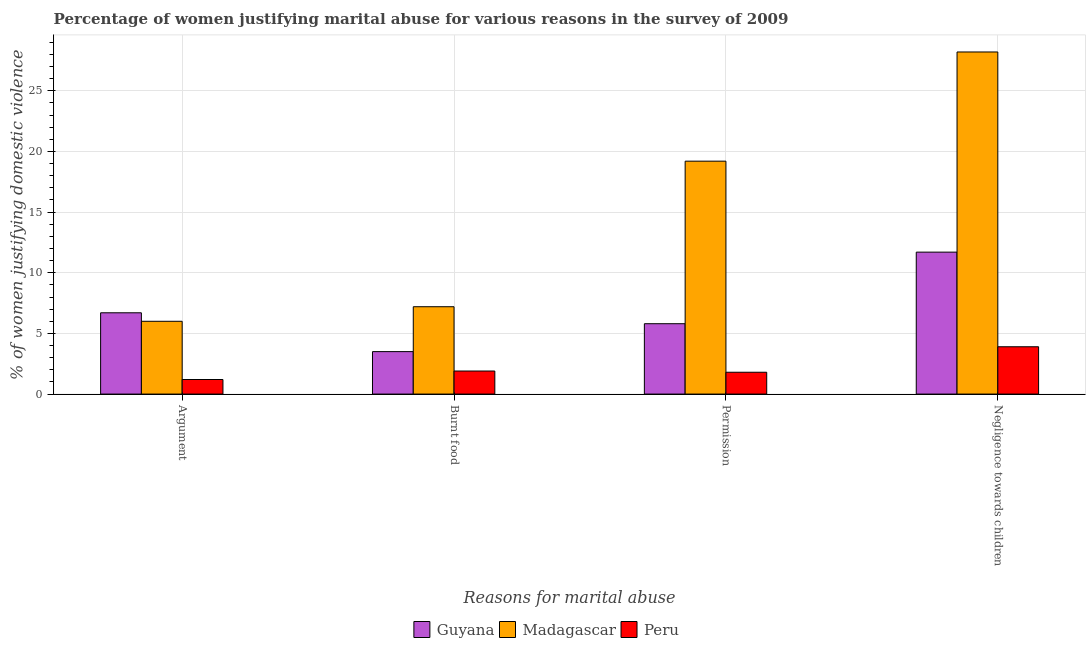How many different coloured bars are there?
Keep it short and to the point. 3. How many groups of bars are there?
Provide a short and direct response. 4. Are the number of bars on each tick of the X-axis equal?
Ensure brevity in your answer.  Yes. How many bars are there on the 1st tick from the left?
Make the answer very short. 3. How many bars are there on the 1st tick from the right?
Provide a succinct answer. 3. What is the label of the 1st group of bars from the left?
Offer a very short reply. Argument. Across all countries, what is the maximum percentage of women justifying abuse for burning food?
Your answer should be very brief. 7.2. Across all countries, what is the minimum percentage of women justifying abuse for going without permission?
Ensure brevity in your answer.  1.8. In which country was the percentage of women justifying abuse in the case of an argument maximum?
Your response must be concise. Guyana. What is the difference between the percentage of women justifying abuse for going without permission in Peru and that in Guyana?
Your answer should be very brief. -4. What is the difference between the percentage of women justifying abuse for burning food in Guyana and the percentage of women justifying abuse for going without permission in Peru?
Make the answer very short. 1.7. What is the average percentage of women justifying abuse for burning food per country?
Offer a terse response. 4.2. In how many countries, is the percentage of women justifying abuse for going without permission greater than 4 %?
Give a very brief answer. 2. What is the ratio of the percentage of women justifying abuse in the case of an argument in Peru to that in Guyana?
Your response must be concise. 0.18. Is the difference between the percentage of women justifying abuse in the case of an argument in Peru and Guyana greater than the difference between the percentage of women justifying abuse for going without permission in Peru and Guyana?
Your response must be concise. No. What is the difference between the highest and the lowest percentage of women justifying abuse for burning food?
Offer a very short reply. 5.3. Is the sum of the percentage of women justifying abuse for going without permission in Peru and Guyana greater than the maximum percentage of women justifying abuse for burning food across all countries?
Offer a terse response. Yes. What does the 3rd bar from the left in Negligence towards children represents?
Offer a very short reply. Peru. What does the 2nd bar from the right in Argument represents?
Your answer should be compact. Madagascar. Are all the bars in the graph horizontal?
Give a very brief answer. No. What is the difference between two consecutive major ticks on the Y-axis?
Provide a short and direct response. 5. Does the graph contain any zero values?
Your response must be concise. No. How many legend labels are there?
Make the answer very short. 3. What is the title of the graph?
Provide a short and direct response. Percentage of women justifying marital abuse for various reasons in the survey of 2009. Does "Ukraine" appear as one of the legend labels in the graph?
Make the answer very short. No. What is the label or title of the X-axis?
Ensure brevity in your answer.  Reasons for marital abuse. What is the label or title of the Y-axis?
Keep it short and to the point. % of women justifying domestic violence. What is the % of women justifying domestic violence in Madagascar in Argument?
Keep it short and to the point. 6. What is the % of women justifying domestic violence in Peru in Argument?
Provide a short and direct response. 1.2. What is the % of women justifying domestic violence of Guyana in Burnt food?
Keep it short and to the point. 3.5. What is the % of women justifying domestic violence in Madagascar in Burnt food?
Ensure brevity in your answer.  7.2. What is the % of women justifying domestic violence in Peru in Burnt food?
Provide a short and direct response. 1.9. What is the % of women justifying domestic violence in Guyana in Permission?
Provide a succinct answer. 5.8. What is the % of women justifying domestic violence in Madagascar in Permission?
Your answer should be compact. 19.2. What is the % of women justifying domestic violence in Peru in Permission?
Provide a short and direct response. 1.8. What is the % of women justifying domestic violence in Madagascar in Negligence towards children?
Offer a terse response. 28.2. Across all Reasons for marital abuse, what is the maximum % of women justifying domestic violence of Madagascar?
Give a very brief answer. 28.2. Across all Reasons for marital abuse, what is the maximum % of women justifying domestic violence in Peru?
Make the answer very short. 3.9. Across all Reasons for marital abuse, what is the minimum % of women justifying domestic violence of Guyana?
Keep it short and to the point. 3.5. Across all Reasons for marital abuse, what is the minimum % of women justifying domestic violence of Peru?
Offer a terse response. 1.2. What is the total % of women justifying domestic violence of Guyana in the graph?
Your answer should be compact. 27.7. What is the total % of women justifying domestic violence of Madagascar in the graph?
Your response must be concise. 60.6. What is the difference between the % of women justifying domestic violence in Peru in Argument and that in Burnt food?
Provide a short and direct response. -0.7. What is the difference between the % of women justifying domestic violence of Guyana in Argument and that in Negligence towards children?
Offer a terse response. -5. What is the difference between the % of women justifying domestic violence in Madagascar in Argument and that in Negligence towards children?
Provide a succinct answer. -22.2. What is the difference between the % of women justifying domestic violence of Peru in Argument and that in Negligence towards children?
Provide a succinct answer. -2.7. What is the difference between the % of women justifying domestic violence in Madagascar in Burnt food and that in Permission?
Your answer should be compact. -12. What is the difference between the % of women justifying domestic violence of Guyana in Burnt food and that in Negligence towards children?
Give a very brief answer. -8.2. What is the difference between the % of women justifying domestic violence of Madagascar in Burnt food and that in Negligence towards children?
Provide a succinct answer. -21. What is the difference between the % of women justifying domestic violence in Peru in Burnt food and that in Negligence towards children?
Your answer should be compact. -2. What is the difference between the % of women justifying domestic violence of Madagascar in Permission and that in Negligence towards children?
Provide a succinct answer. -9. What is the difference between the % of women justifying domestic violence of Peru in Permission and that in Negligence towards children?
Ensure brevity in your answer.  -2.1. What is the difference between the % of women justifying domestic violence of Madagascar in Argument and the % of women justifying domestic violence of Peru in Permission?
Your answer should be very brief. 4.2. What is the difference between the % of women justifying domestic violence of Guyana in Argument and the % of women justifying domestic violence of Madagascar in Negligence towards children?
Provide a short and direct response. -21.5. What is the difference between the % of women justifying domestic violence of Guyana in Burnt food and the % of women justifying domestic violence of Madagascar in Permission?
Your answer should be very brief. -15.7. What is the difference between the % of women justifying domestic violence in Guyana in Burnt food and the % of women justifying domestic violence in Peru in Permission?
Make the answer very short. 1.7. What is the difference between the % of women justifying domestic violence in Guyana in Burnt food and the % of women justifying domestic violence in Madagascar in Negligence towards children?
Ensure brevity in your answer.  -24.7. What is the difference between the % of women justifying domestic violence of Madagascar in Burnt food and the % of women justifying domestic violence of Peru in Negligence towards children?
Give a very brief answer. 3.3. What is the difference between the % of women justifying domestic violence of Guyana in Permission and the % of women justifying domestic violence of Madagascar in Negligence towards children?
Your answer should be very brief. -22.4. What is the difference between the % of women justifying domestic violence of Guyana in Permission and the % of women justifying domestic violence of Peru in Negligence towards children?
Give a very brief answer. 1.9. What is the difference between the % of women justifying domestic violence in Madagascar in Permission and the % of women justifying domestic violence in Peru in Negligence towards children?
Your answer should be compact. 15.3. What is the average % of women justifying domestic violence in Guyana per Reasons for marital abuse?
Your answer should be compact. 6.92. What is the average % of women justifying domestic violence in Madagascar per Reasons for marital abuse?
Ensure brevity in your answer.  15.15. What is the difference between the % of women justifying domestic violence in Guyana and % of women justifying domestic violence in Madagascar in Argument?
Offer a very short reply. 0.7. What is the difference between the % of women justifying domestic violence in Madagascar and % of women justifying domestic violence in Peru in Argument?
Make the answer very short. 4.8. What is the difference between the % of women justifying domestic violence in Guyana and % of women justifying domestic violence in Peru in Burnt food?
Ensure brevity in your answer.  1.6. What is the difference between the % of women justifying domestic violence in Guyana and % of women justifying domestic violence in Madagascar in Permission?
Give a very brief answer. -13.4. What is the difference between the % of women justifying domestic violence in Guyana and % of women justifying domestic violence in Madagascar in Negligence towards children?
Ensure brevity in your answer.  -16.5. What is the difference between the % of women justifying domestic violence of Guyana and % of women justifying domestic violence of Peru in Negligence towards children?
Make the answer very short. 7.8. What is the difference between the % of women justifying domestic violence of Madagascar and % of women justifying domestic violence of Peru in Negligence towards children?
Make the answer very short. 24.3. What is the ratio of the % of women justifying domestic violence of Guyana in Argument to that in Burnt food?
Make the answer very short. 1.91. What is the ratio of the % of women justifying domestic violence of Peru in Argument to that in Burnt food?
Ensure brevity in your answer.  0.63. What is the ratio of the % of women justifying domestic violence of Guyana in Argument to that in Permission?
Your response must be concise. 1.16. What is the ratio of the % of women justifying domestic violence in Madagascar in Argument to that in Permission?
Your answer should be very brief. 0.31. What is the ratio of the % of women justifying domestic violence of Peru in Argument to that in Permission?
Your answer should be very brief. 0.67. What is the ratio of the % of women justifying domestic violence of Guyana in Argument to that in Negligence towards children?
Your answer should be compact. 0.57. What is the ratio of the % of women justifying domestic violence in Madagascar in Argument to that in Negligence towards children?
Keep it short and to the point. 0.21. What is the ratio of the % of women justifying domestic violence in Peru in Argument to that in Negligence towards children?
Keep it short and to the point. 0.31. What is the ratio of the % of women justifying domestic violence of Guyana in Burnt food to that in Permission?
Keep it short and to the point. 0.6. What is the ratio of the % of women justifying domestic violence in Madagascar in Burnt food to that in Permission?
Your answer should be compact. 0.38. What is the ratio of the % of women justifying domestic violence in Peru in Burnt food to that in Permission?
Ensure brevity in your answer.  1.06. What is the ratio of the % of women justifying domestic violence of Guyana in Burnt food to that in Negligence towards children?
Ensure brevity in your answer.  0.3. What is the ratio of the % of women justifying domestic violence in Madagascar in Burnt food to that in Negligence towards children?
Ensure brevity in your answer.  0.26. What is the ratio of the % of women justifying domestic violence of Peru in Burnt food to that in Negligence towards children?
Keep it short and to the point. 0.49. What is the ratio of the % of women justifying domestic violence in Guyana in Permission to that in Negligence towards children?
Give a very brief answer. 0.5. What is the ratio of the % of women justifying domestic violence of Madagascar in Permission to that in Negligence towards children?
Give a very brief answer. 0.68. What is the ratio of the % of women justifying domestic violence in Peru in Permission to that in Negligence towards children?
Give a very brief answer. 0.46. What is the difference between the highest and the second highest % of women justifying domestic violence of Guyana?
Provide a short and direct response. 5. What is the difference between the highest and the second highest % of women justifying domestic violence in Madagascar?
Provide a succinct answer. 9. What is the difference between the highest and the lowest % of women justifying domestic violence in Guyana?
Make the answer very short. 8.2. What is the difference between the highest and the lowest % of women justifying domestic violence in Madagascar?
Provide a short and direct response. 22.2. What is the difference between the highest and the lowest % of women justifying domestic violence of Peru?
Your answer should be compact. 2.7. 